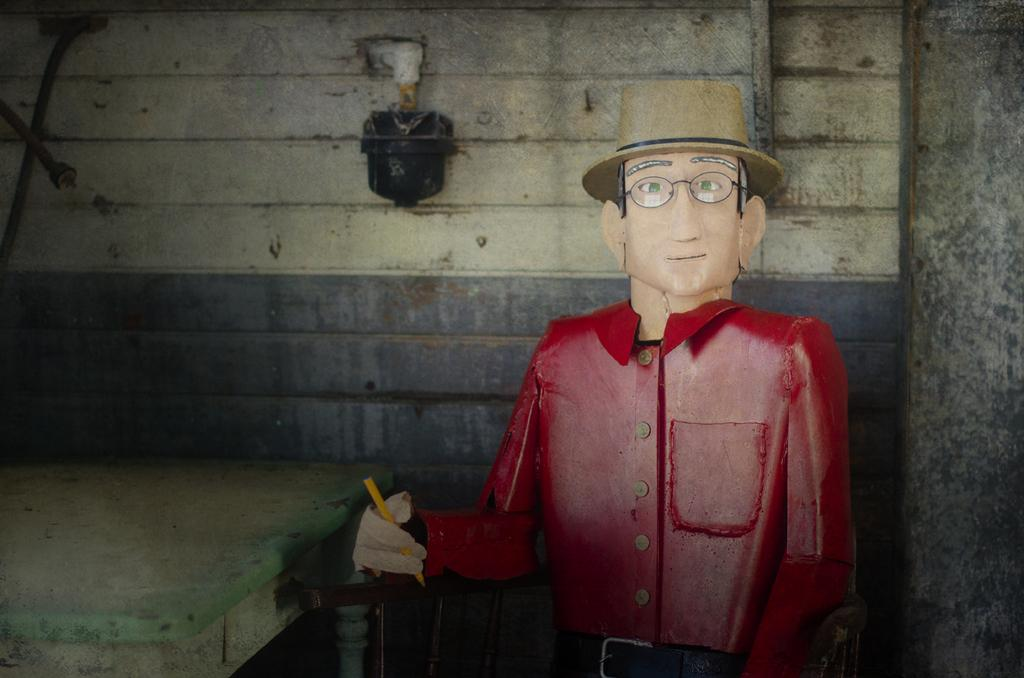What is the main subject of the image? There is a sculpture in the image. How is the sculpture positioned in the image? The sculpture is made to sit on a chair. What other furniture is present in the image? There is a table in the image. What can be seen in the background of the image? There is a wall in the background of the image. What type of riddle is the sculpture trying to solve in the image? There is no riddle present in the image, and the sculpture is not depicted as engaging in any activity. 